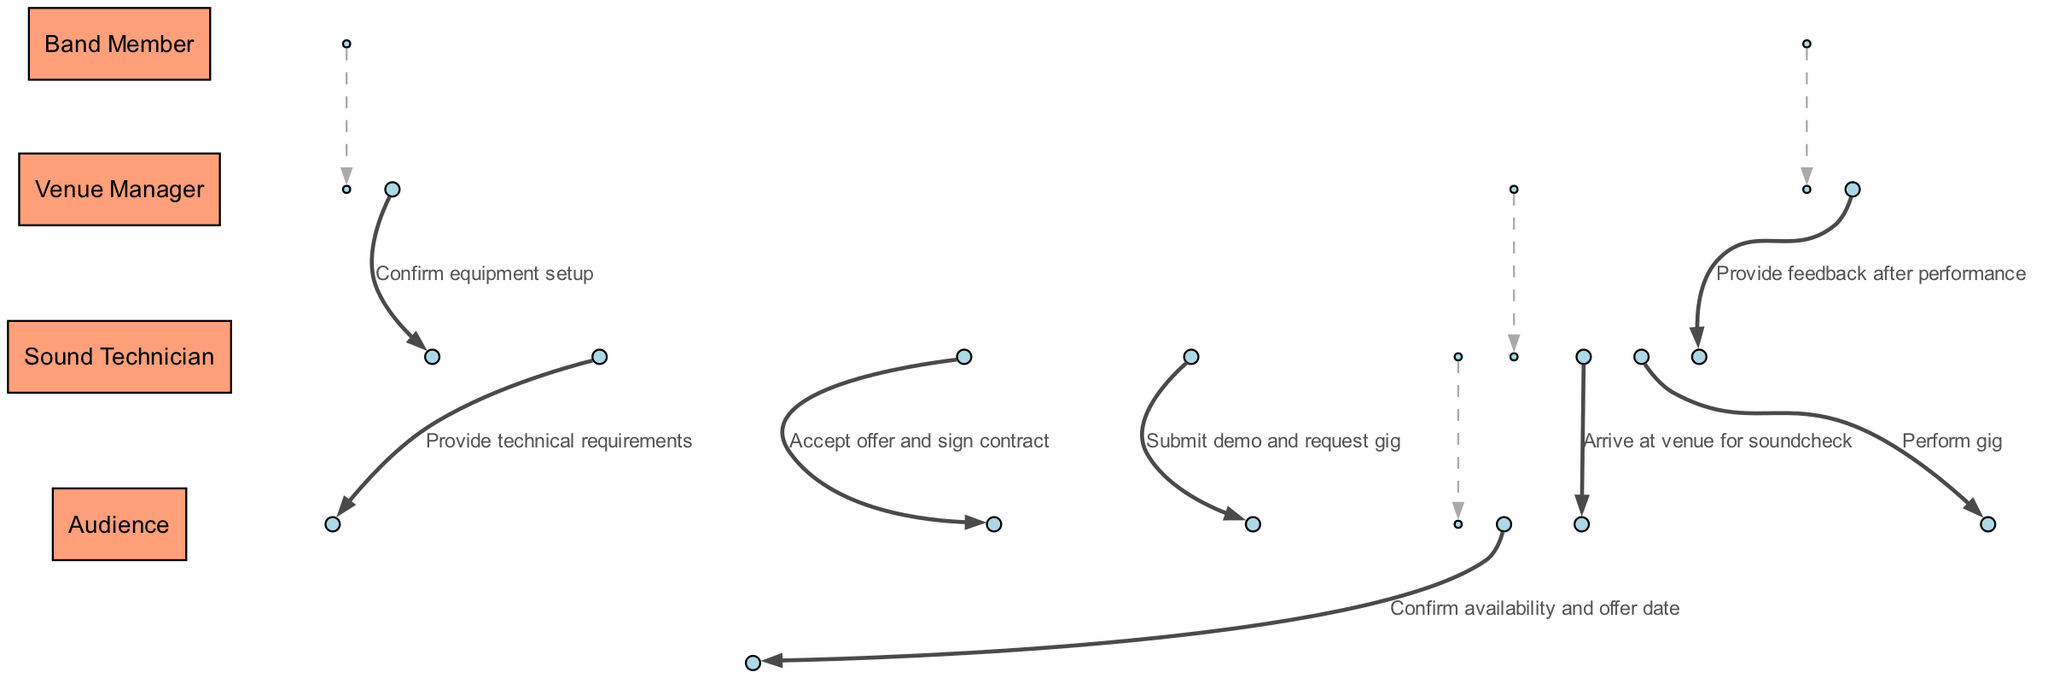What is the first action taken by the Band Member? The diagram indicates that the first action taken by the Band Member is to submit a demo and request a gig. This is represented by the arrow originating from the Band Member to the Venue Manager with the specified message.
Answer: Submit demo and request gig How many actors are involved in the booking process? By examining the diagram, we can count the actors listed: Band Member, Venue Manager, Sound Technician, and Audience. This totals to four distinct actors, each playing a role in the process.
Answer: 4 What message does the Sound Technician send to the Band Member? In the sequence provided, the Sound Technician confirms the equipment setup in response to the Band Member's request. This message is conveyed through an arrow from Sound Technician to Band Member with the specified label.
Answer: Confirm equipment setup Who does the Band Member provide technical requirements to? The diagram shows that the Band Member communicates the technical requirements specifically to the Sound Technician. This is indicated by the directed message from Band Member to Sound Technician.
Answer: Sound Technician What action follows the Band Member arriving at the venue for soundcheck? According to the sequence depicted, the Band Member's arrival at the venue for a soundcheck is directly followed by the performance of the gig to the audience. The flow of actions illustrates this connection.
Answer: Perform gig How many messages are exchanged between the Band Member and Venue Manager? By analyzing the diagram, we note that there are three distinct interactions between the Band Member and the Venue Manager: submitting the demo, accepting the offer, and arriving for soundcheck. Each of these exchanges is represented by arrows in the sequence.
Answer: 3 What type of feedback does the Audience provide to the Band Member? The last interaction in the sequence indicates that the Audience provides feedback after the performance is completed. This is specified in the directed arrow moving from Audience to Band Member with the respective message.
Answer: Provide feedback after performance What step follows the signing of the contract by the Band Member? After the Band Member accepts the offer and signs the contract, the next step shown in the diagram is for the Band Member to provide technical requirements to the Sound Technician. This connection is sequentially outlined in the process.
Answer: Provide technical requirements Which actor is the last to interact in the sequence? Observing the sequence of messages, the last actor to interact is the Audience, as they provide feedback to the Band Member after the performance. This final action completes the sequence of events.
Answer: Audience 